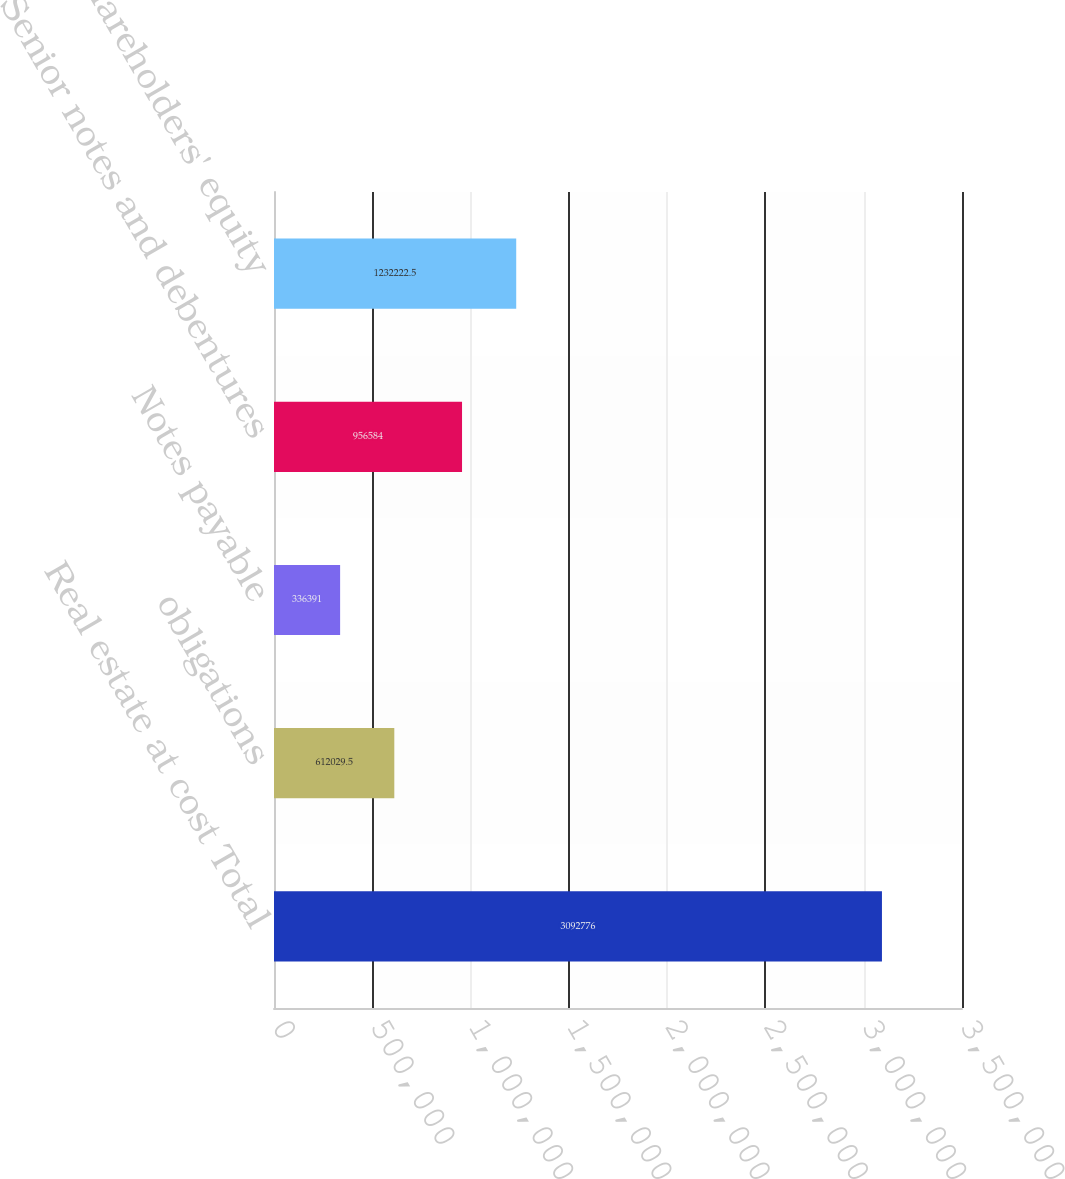Convert chart to OTSL. <chart><loc_0><loc_0><loc_500><loc_500><bar_chart><fcel>Real estate at cost Total<fcel>obligations<fcel>Notes payable<fcel>Senior notes and debentures<fcel>Shareholders' equity<nl><fcel>3.09278e+06<fcel>612030<fcel>336391<fcel>956584<fcel>1.23222e+06<nl></chart> 